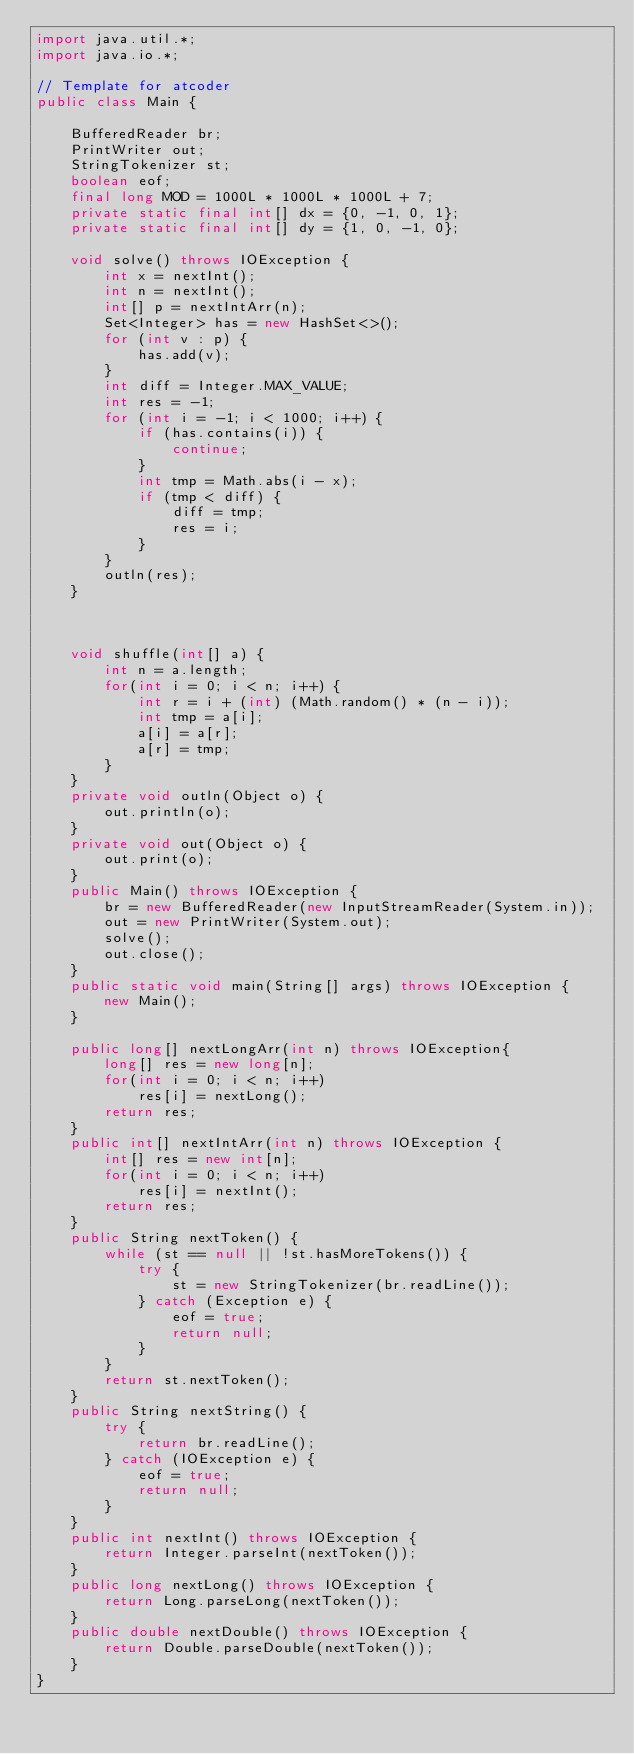Convert code to text. <code><loc_0><loc_0><loc_500><loc_500><_Java_>import java.util.*;
import java.io.*;

// Template for atcoder
public class Main {

    BufferedReader br;
    PrintWriter out;
    StringTokenizer st;
    boolean eof;
    final long MOD = 1000L * 1000L * 1000L + 7;
    private static final int[] dx = {0, -1, 0, 1};
    private static final int[] dy = {1, 0, -1, 0};

    void solve() throws IOException {
        int x = nextInt();
        int n = nextInt();
        int[] p = nextIntArr(n);
        Set<Integer> has = new HashSet<>();
        for (int v : p) {
            has.add(v);
        }
        int diff = Integer.MAX_VALUE;
        int res = -1;
        for (int i = -1; i < 1000; i++) {
            if (has.contains(i)) {
                continue;
            }
            int tmp = Math.abs(i - x);
            if (tmp < diff) {
                diff = tmp;
                res = i;
            }
        }
        outln(res);
    }



    void shuffle(int[] a) {
        int n = a.length;
        for(int i = 0; i < n; i++) {
            int r = i + (int) (Math.random() * (n - i));
            int tmp = a[i];
            a[i] = a[r];
            a[r] = tmp;
        }
    }
    private void outln(Object o) {
        out.println(o);
    }
    private void out(Object o) {
        out.print(o);
    }
    public Main() throws IOException {
        br = new BufferedReader(new InputStreamReader(System.in));
        out = new PrintWriter(System.out);
        solve();
        out.close();
    }
    public static void main(String[] args) throws IOException {
        new Main();
    }

    public long[] nextLongArr(int n) throws IOException{
        long[] res = new long[n];
        for(int i = 0; i < n; i++)
            res[i] = nextLong();
        return res;
    }
    public int[] nextIntArr(int n) throws IOException {
        int[] res = new int[n];
        for(int i = 0; i < n; i++)
            res[i] = nextInt();
        return res;
    }
    public String nextToken() {
        while (st == null || !st.hasMoreTokens()) {
            try {
                st = new StringTokenizer(br.readLine());
            } catch (Exception e) {
                eof = true;
                return null;
            }
        }
        return st.nextToken();
    }
    public String nextString() {
        try {
            return br.readLine();
        } catch (IOException e) {
            eof = true;
            return null;
        }
    }
    public int nextInt() throws IOException {
        return Integer.parseInt(nextToken());
    }
    public long nextLong() throws IOException {
        return Long.parseLong(nextToken());
    }
    public double nextDouble() throws IOException {
        return Double.parseDouble(nextToken());
    }
}
</code> 